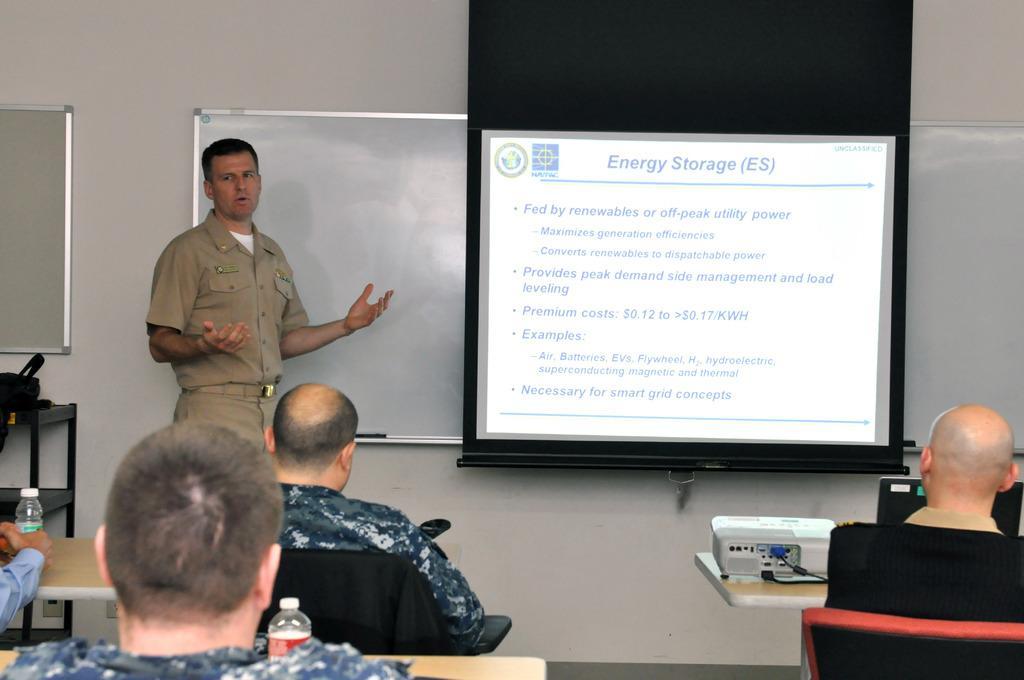Describe this image in one or two sentences. In this image there is a man standing on the floor by raising his hands. Behind him there is a whiteboard. Beside him there is a screen. At the bottom there are few people sitting in the chairs. In front of them there are tables on which there are bottles. On the right side there is a projector kept on the table. Beside the projector there is a laptop. On the right side bottom there is a person sitting in the chair. 